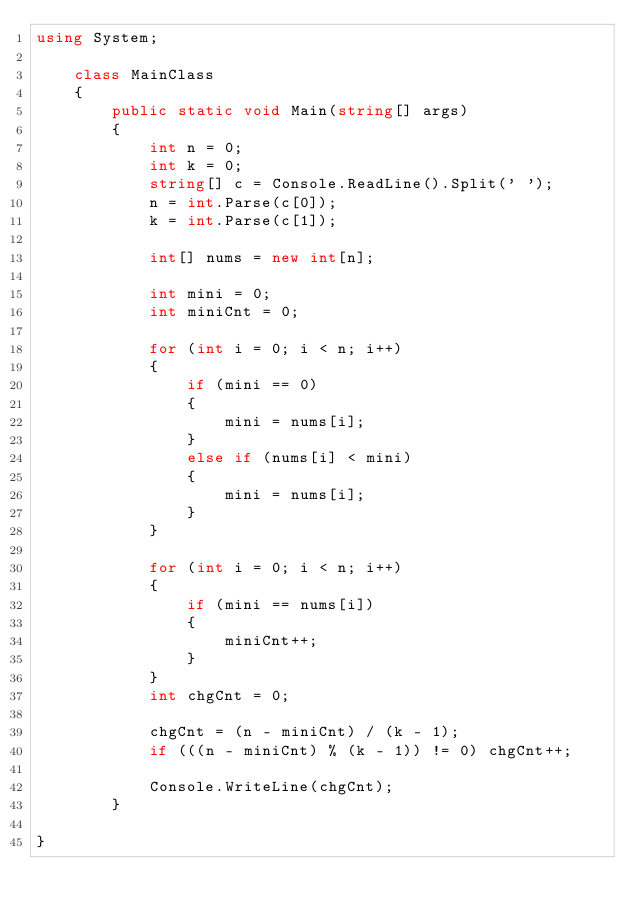Convert code to text. <code><loc_0><loc_0><loc_500><loc_500><_C#_>using System;

	class MainClass
	{
		public static void Main(string[] args)
		{
			int n = 0;
			int k = 0;
			string[] c = Console.ReadLine().Split(' ');
			n = int.Parse(c[0]);
			k = int.Parse(c[1]);

			int[] nums = new int[n];

			int mini = 0;
			int miniCnt = 0;

			for (int i = 0; i < n; i++)
			{
				if (mini == 0)
				{
					mini = nums[i];
				}
				else if (nums[i] < mini)
				{
					mini = nums[i];
				}
			}

			for (int i = 0; i < n; i++)
			{
				if (mini == nums[i])
				{
					miniCnt++;
				}
			}
			int chgCnt = 0;

			chgCnt = (n - miniCnt) / (k - 1);
			if (((n - miniCnt) % (k - 1)) != 0) chgCnt++;

			Console.WriteLine(chgCnt);
		}
	
}
</code> 